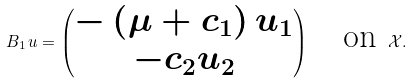<formula> <loc_0><loc_0><loc_500><loc_500>\ B _ { 1 } \, u = \begin{pmatrix} - \left ( \mu + c _ { 1 } \right ) u _ { 1 } \\ - c _ { 2 } u _ { 2 } \end{pmatrix} \quad \text {on} \ \mathcal { X } .</formula> 